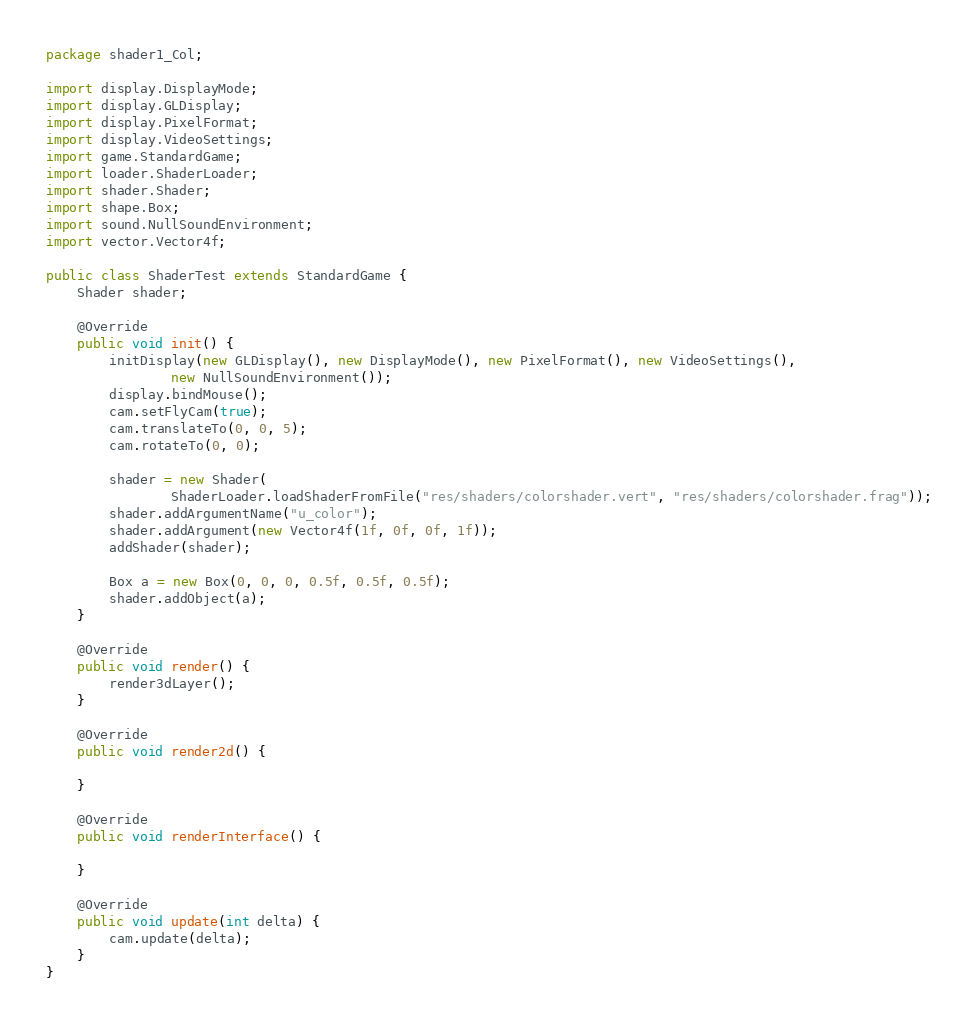<code> <loc_0><loc_0><loc_500><loc_500><_Java_>package shader1_Col;

import display.DisplayMode;
import display.GLDisplay;
import display.PixelFormat;
import display.VideoSettings;
import game.StandardGame;
import loader.ShaderLoader;
import shader.Shader;
import shape.Box;
import sound.NullSoundEnvironment;
import vector.Vector4f;

public class ShaderTest extends StandardGame {
	Shader shader;

	@Override
	public void init() {
		initDisplay(new GLDisplay(), new DisplayMode(), new PixelFormat(), new VideoSettings(),
				new NullSoundEnvironment());
		display.bindMouse();
		cam.setFlyCam(true);
		cam.translateTo(0, 0, 5);
		cam.rotateTo(0, 0);

		shader = new Shader(
				ShaderLoader.loadShaderFromFile("res/shaders/colorshader.vert", "res/shaders/colorshader.frag"));
		shader.addArgumentName("u_color");
		shader.addArgument(new Vector4f(1f, 0f, 0f, 1f));
		addShader(shader);

		Box a = new Box(0, 0, 0, 0.5f, 0.5f, 0.5f);
		shader.addObject(a);
	}

	@Override
	public void render() {
		render3dLayer();
	}

	@Override
	public void render2d() {

	}

	@Override
	public void renderInterface() {

	}

	@Override
	public void update(int delta) {
		cam.update(delta);
	}
}
</code> 